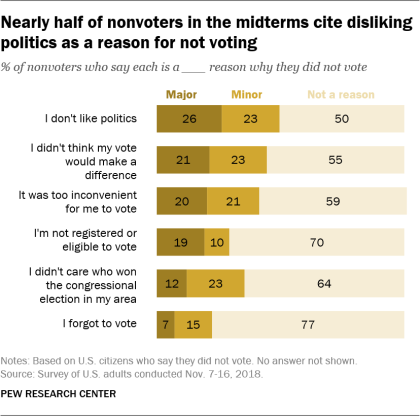Draw attention to some important aspects in this diagram. The total value of Major, Minor, and Not a reason in I don't like politics is 99. I do not register or become eligible to vote is a major reason why I did not vote. In particular, those who do not register or become eligible to vote is a significant factor in explaining why some individuals do not participate in elections. 